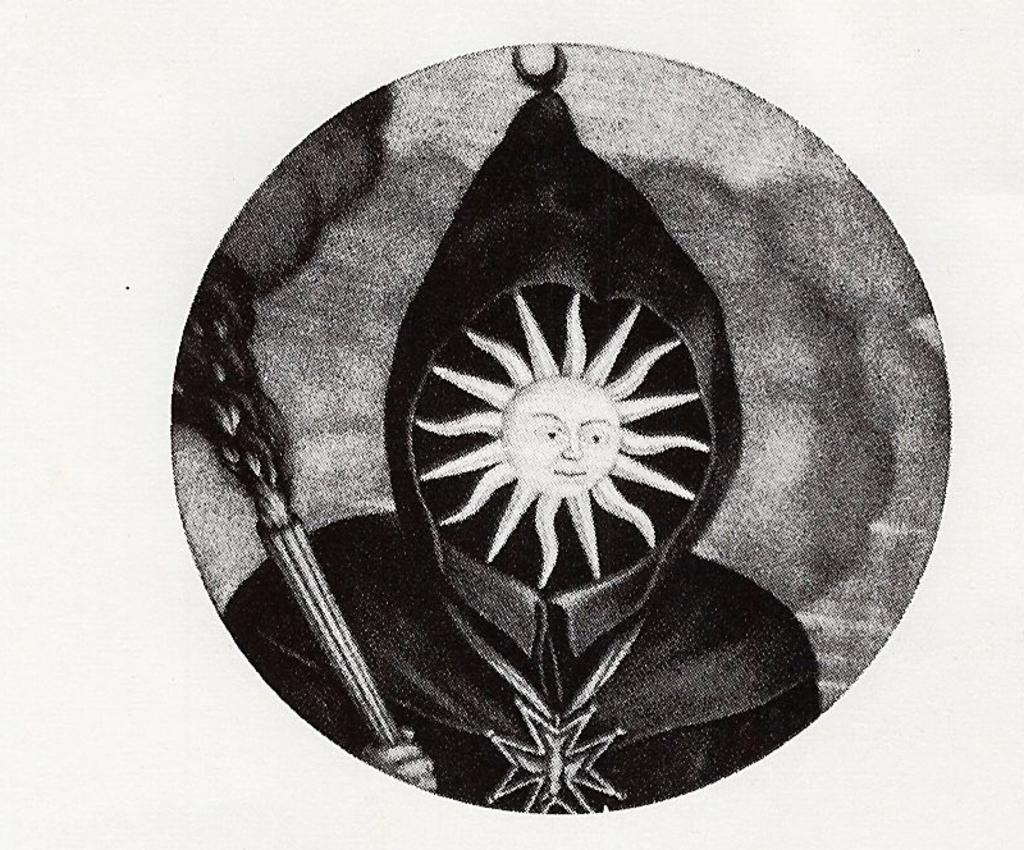What is the color scheme of the image? The image is black and white. What is the main feature of the image? There is a logo in the image. Can you describe the shape of the logo? The logo is in the shape of a circle. What elements are included in the logo? The logo contains a picture of a mask and a picture of the sun. What type of skirt is your mom wearing in the image? There is no image of your mom in this conversation, and the provided facts do not mention any clothing items. 